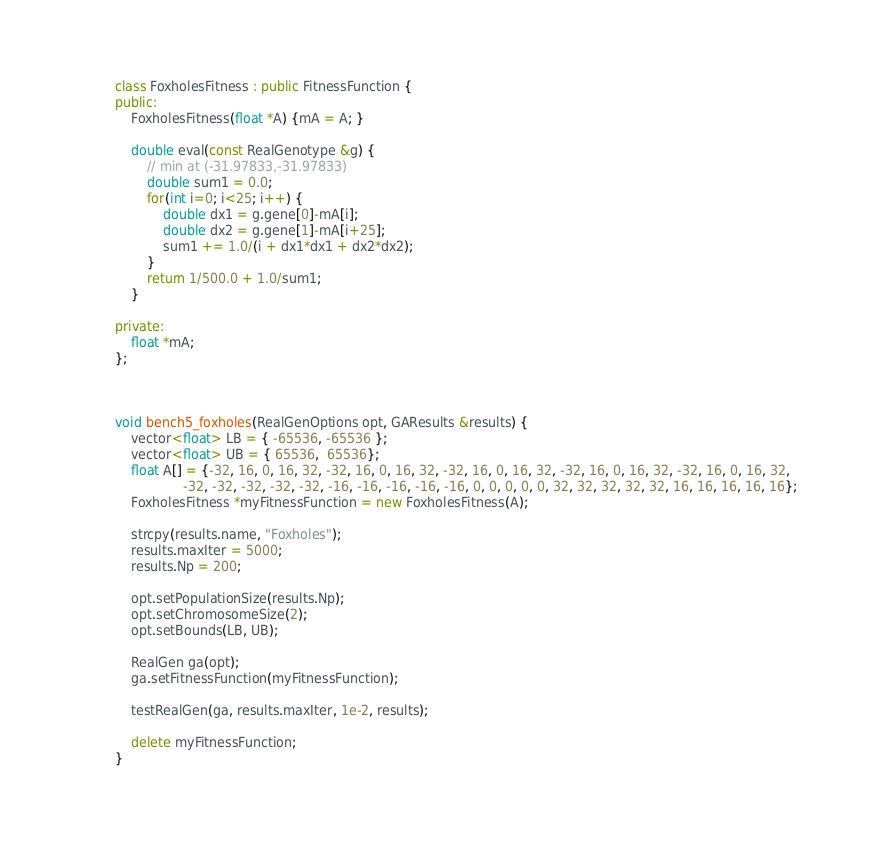Convert code to text. <code><loc_0><loc_0><loc_500><loc_500><_C++_>
class FoxholesFitness : public FitnessFunction {
public:
    FoxholesFitness(float *A) {mA = A; }

    double eval(const RealGenotype &g) {
        // min at (-31.97833,-31.97833)
        double sum1 = 0.0;
        for(int i=0; i<25; i++) {
            double dx1 = g.gene[0]-mA[i];
            double dx2 = g.gene[1]-mA[i+25];
            sum1 += 1.0/(i + dx1*dx1 + dx2*dx2);
        }
        return 1/500.0 + 1.0/sum1;
    }

private:
    float *mA;
};



void bench5_foxholes(RealGenOptions opt, GAResults &results) {
    vector<float> LB = { -65536, -65536 };
    vector<float> UB = { 65536,  65536};
    float A[] = {-32, 16, 0, 16, 32, -32, 16, 0, 16, 32, -32, 16, 0, 16, 32, -32, 16, 0, 16, 32, -32, 16, 0, 16, 32,
                 -32, -32, -32, -32, -32, -16, -16, -16, -16, -16, 0, 0, 0, 0, 0, 32, 32, 32, 32, 32, 16, 16, 16, 16, 16};
    FoxholesFitness *myFitnessFunction = new FoxholesFitness(A);

    strcpy(results.name, "Foxholes");
    results.maxIter = 5000;
    results.Np = 200;

    opt.setPopulationSize(results.Np);
    opt.setChromosomeSize(2);
    opt.setBounds(LB, UB);

    RealGen ga(opt);
    ga.setFitnessFunction(myFitnessFunction);

    testRealGen(ga, results.maxIter, 1e-2, results);

    delete myFitnessFunction;
}
</code> 